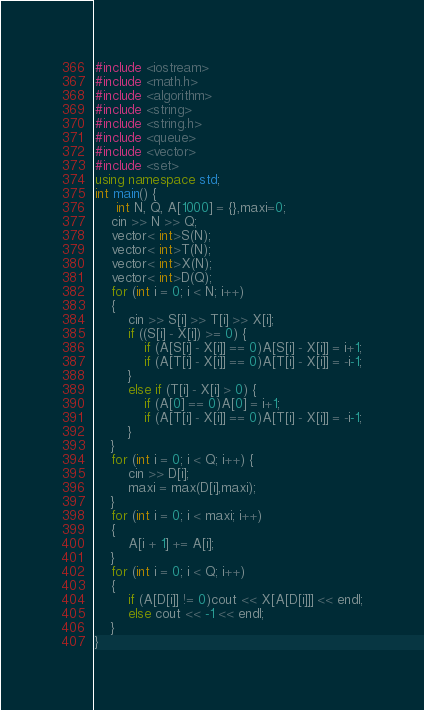<code> <loc_0><loc_0><loc_500><loc_500><_C++_>#include <iostream>
#include <math.h>
#include <algorithm>
#include <string>
#include <string.h>
#include <queue>
#include <vector>
#include <set>
using namespace std;
int main() {
	 int N, Q, A[1000] = {},maxi=0;
	cin >> N >> Q;
	vector< int>S(N);
	vector< int>T(N);
	vector< int>X(N);
	vector< int>D(Q);
	for (int i = 0; i < N; i++)
	{
		cin >> S[i] >> T[i] >> X[i];
		if ((S[i] - X[i]) >= 0) {
			if (A[S[i] - X[i]] == 0)A[S[i] - X[i]] = i+1;
			if (A[T[i] - X[i]] == 0)A[T[i] - X[i]] = -i-1;
		}
		else if (T[i] - X[i] > 0) {
			if (A[0] == 0)A[0] = i+1;
			if (A[T[i] - X[i]] == 0)A[T[i] - X[i]] = -i-1;
		}
	}
	for (int i = 0; i < Q; i++) {
		cin >> D[i];
		maxi = max(D[i],maxi);
	}
	for (int i = 0; i < maxi; i++)
	{
		A[i + 1] += A[i];
	}
	for (int i = 0; i < Q; i++)
	{
		if (A[D[i]] != 0)cout << X[A[D[i]]] << endl;
		else cout << -1 << endl;
	}
}</code> 